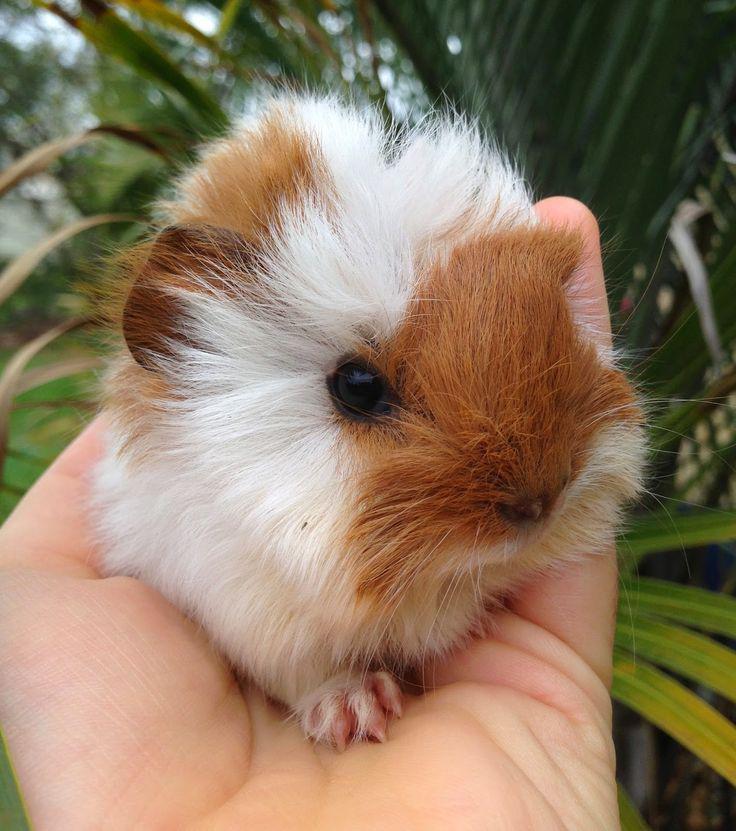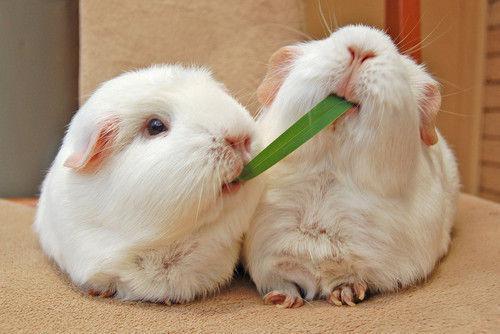The first image is the image on the left, the second image is the image on the right. Analyze the images presented: Is the assertion "One of the images includes part of a human." valid? Answer yes or no. Yes. The first image is the image on the left, the second image is the image on the right. Analyze the images presented: Is the assertion "In one image there are two guinea pigs eating grass." valid? Answer yes or no. Yes. 